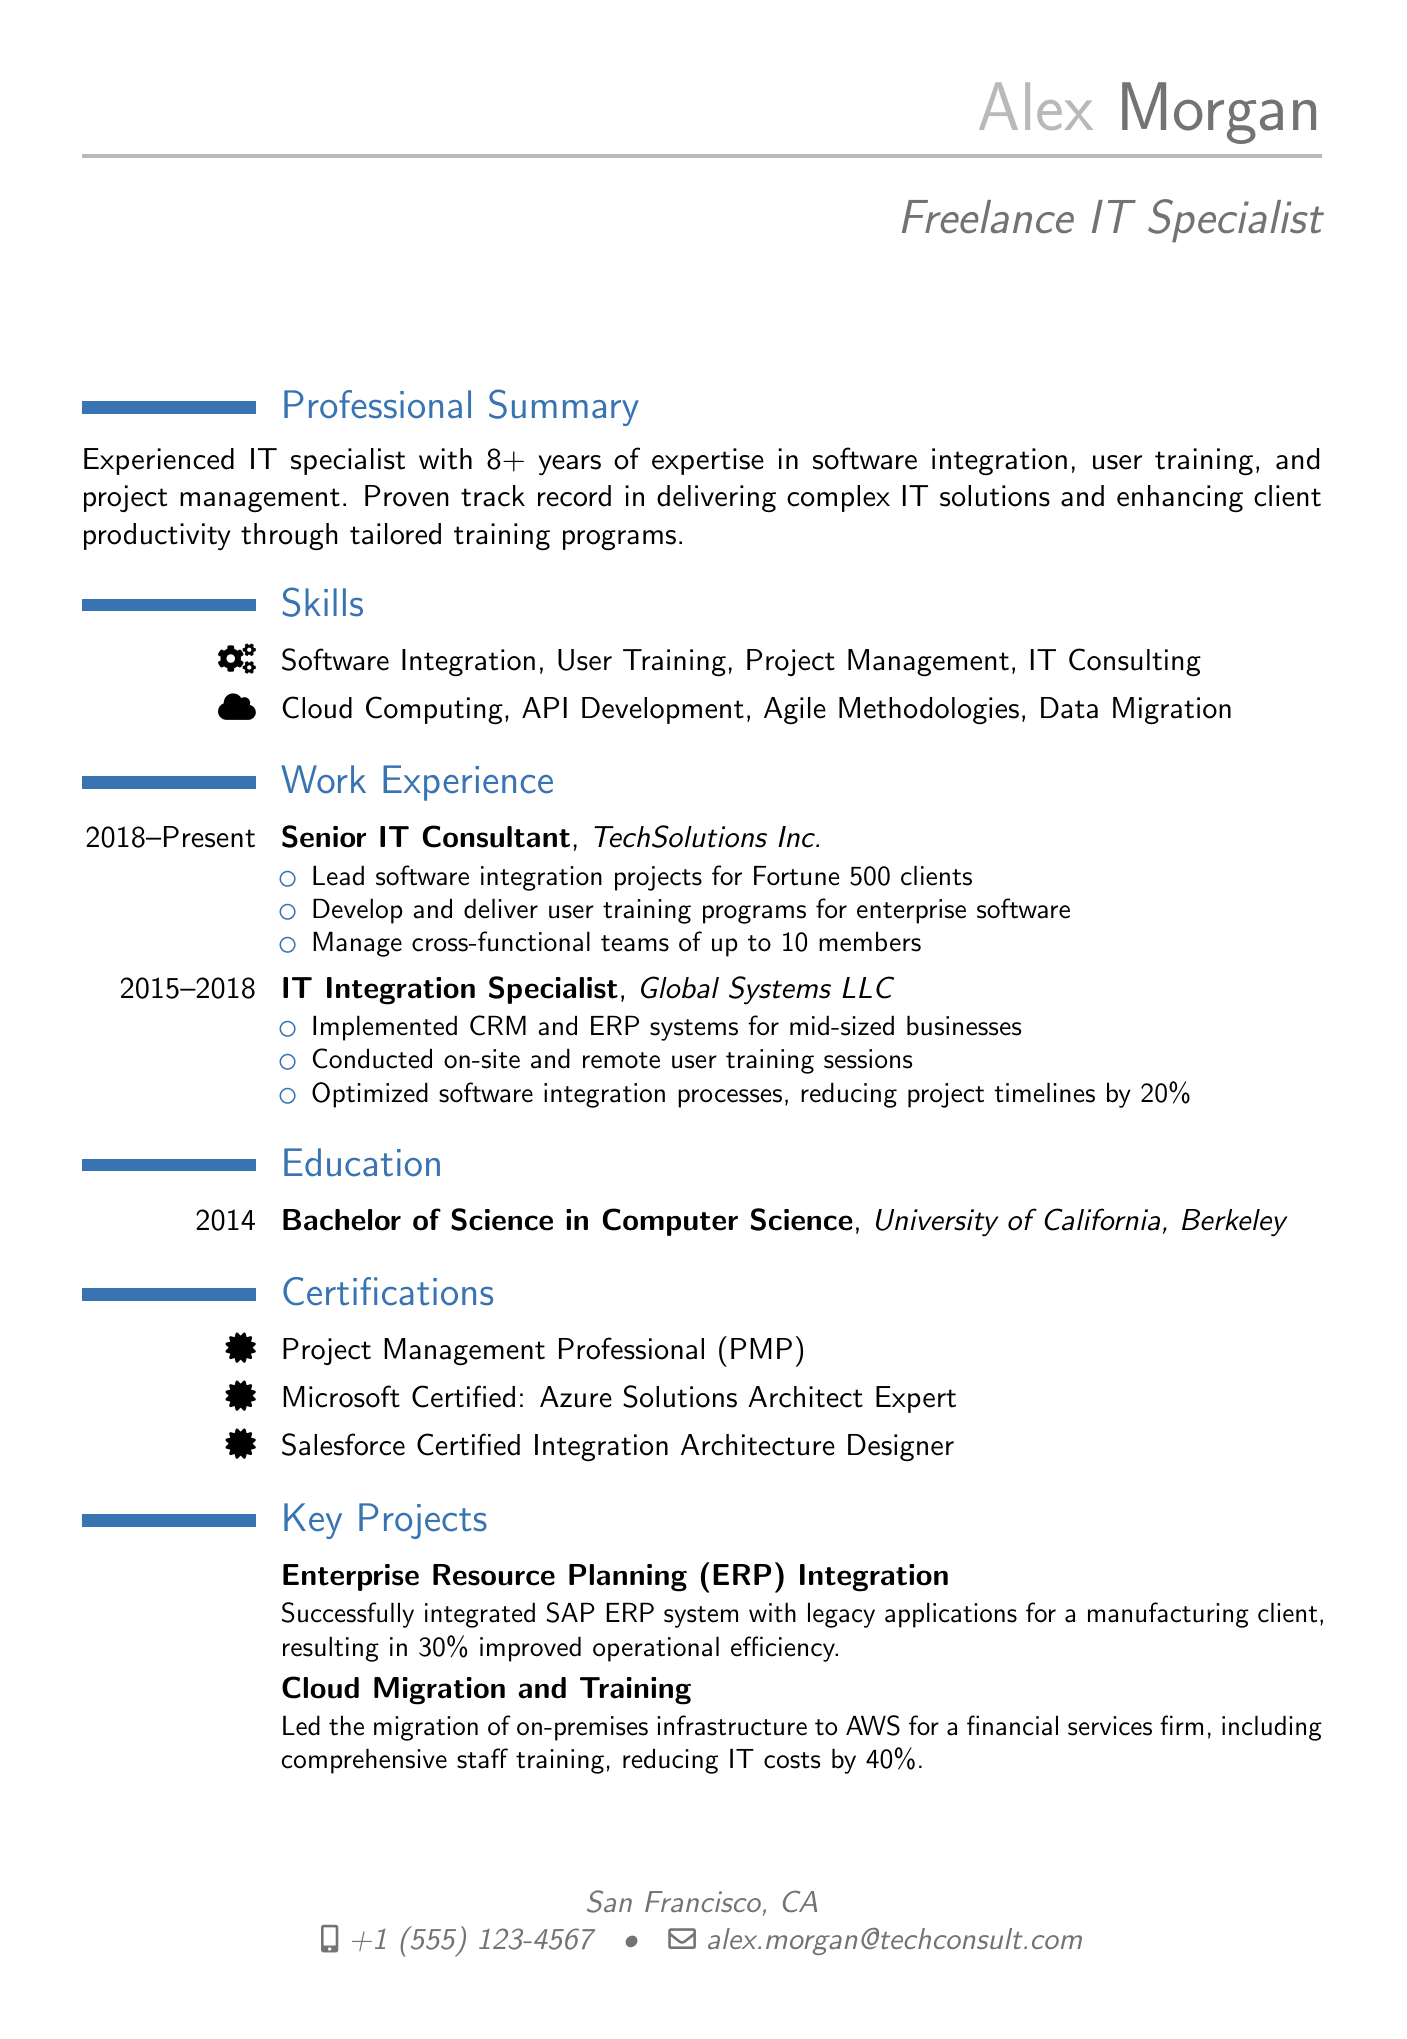what is the name of the freelance IT specialist? The name is provided in the personal information section of the CV.
Answer: Alex Morgan how many years of experience does the specialist have? The professional summary states the amount of experience the specialist has in the field.
Answer: 8+ years which company does the specialist currently work for? The work experience section lists the current employer of the specialist.
Answer: TechSolutions Inc what is one of the skills listed in the CV? The skills section outlines various capabilities of the specialist.
Answer: Software Integration what degree did Alex Morgan earn? The education section details the academic qualification achieved by the specialist.
Answer: Bachelor of Science in Computer Science which certification indicates expertise in project management? The certifications section includes various credentials the specialist holds.
Answer: Project Management Professional (PMP) what is the result of the ERP integration project? The projects section describes the outcomes of key initiatives involving IT solutions.
Answer: 30% improved operational efficiency how long did Alex work at Global Systems LLC? The work experience section indicates the duration of employment at this company.
Answer: 3 years what was reduced by 40% due to the cloud migration project? The projects section mentions the financial impact of a specific project undertaken by the specialist.
Answer: IT costs 